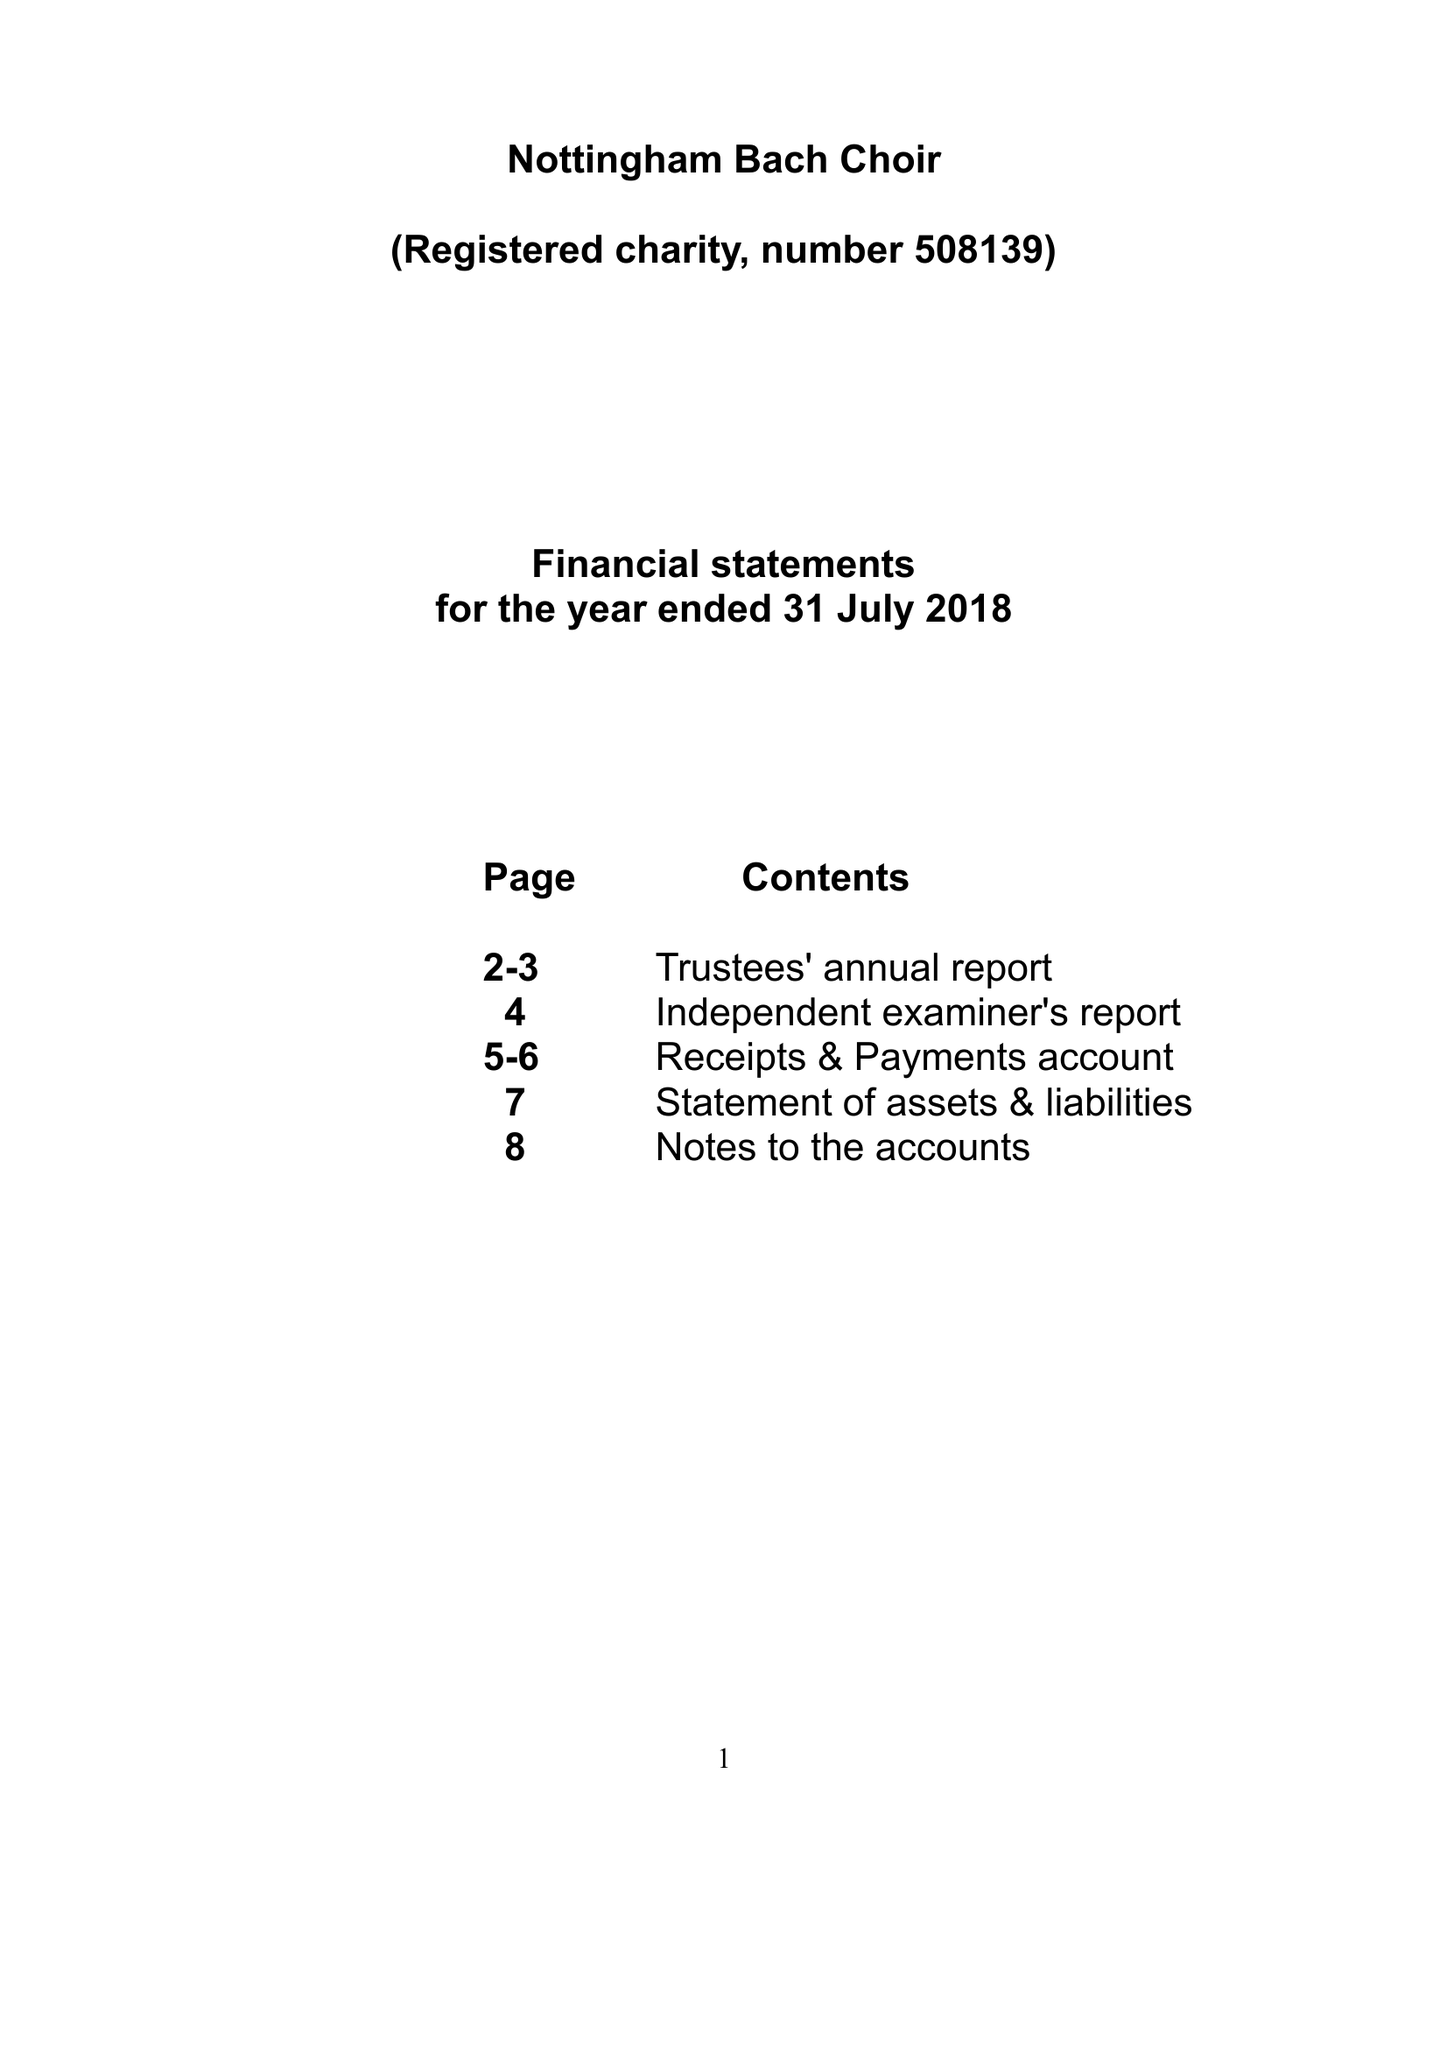What is the value for the income_annually_in_british_pounds?
Answer the question using a single word or phrase. 34637.14 